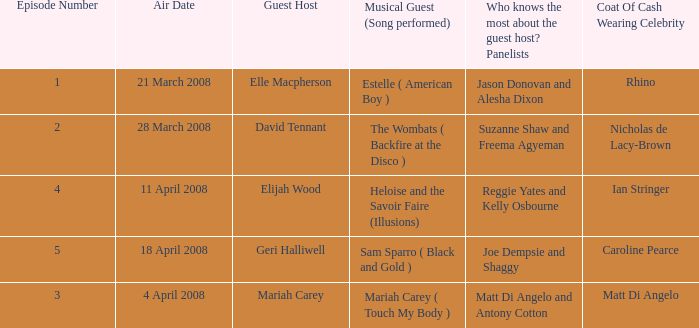Name the least number of episodes for the panelists of reggie yates and kelly osbourne 4.0. 